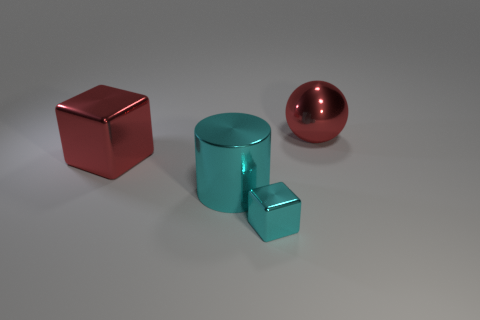Is there a red sphere of the same size as the red metal block?
Offer a terse response. Yes. Are there more cyan objects that are in front of the large cylinder than large cubes in front of the large red metal cube?
Make the answer very short. Yes. Does the tiny block have the same material as the cube on the left side of the cyan cylinder?
Keep it short and to the point. Yes. What number of large red things are behind the big red block behind the large thing in front of the large red metallic block?
Keep it short and to the point. 1. Do the large cyan thing and the big red object that is to the right of the red metal cube have the same shape?
Give a very brief answer. No. There is a object that is both behind the big cyan shiny cylinder and on the right side of the big cyan metallic cylinder; what color is it?
Ensure brevity in your answer.  Red. What material is the big red thing in front of the big red ball behind the shiny object that is to the left of the metal cylinder made of?
Your answer should be very brief. Metal. What material is the big cylinder?
Offer a terse response. Metal. The red metallic object that is the same shape as the tiny cyan metal thing is what size?
Offer a terse response. Large. Is the color of the cylinder the same as the metallic sphere?
Ensure brevity in your answer.  No. 